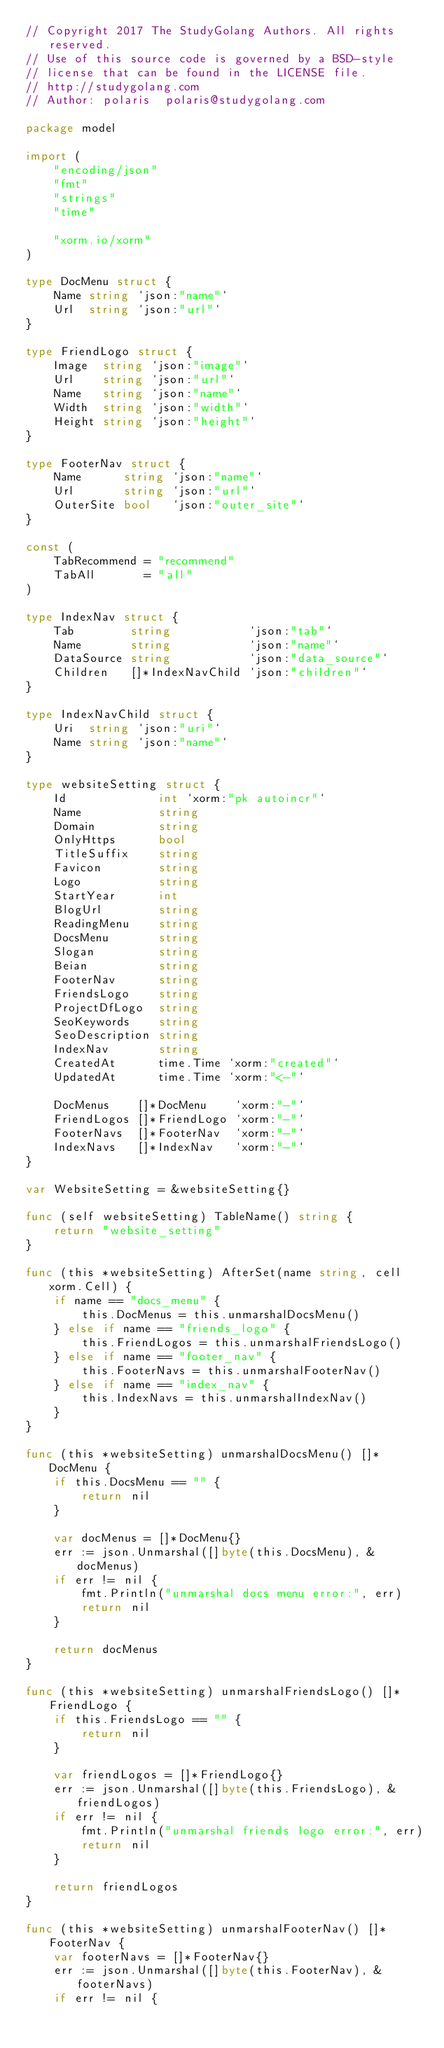<code> <loc_0><loc_0><loc_500><loc_500><_Go_>// Copyright 2017 The StudyGolang Authors. All rights reserved.
// Use of this source code is governed by a BSD-style
// license that can be found in the LICENSE file.
// http://studygolang.com
// Author: polaris	polaris@studygolang.com

package model

import (
	"encoding/json"
	"fmt"
	"strings"
	"time"

	"xorm.io/xorm"
)

type DocMenu struct {
	Name string `json:"name"`
	Url  string `json:"url"`
}

type FriendLogo struct {
	Image  string `json:"image"`
	Url    string `json:"url"`
	Name   string `json:"name"`
	Width  string `json:"width"`
	Height string `json:"height"`
}

type FooterNav struct {
	Name      string `json:"name"`
	Url       string `json:"url"`
	OuterSite bool   `json:"outer_site"`
}

const (
	TabRecommend = "recommend"
	TabAll       = "all"
)

type IndexNav struct {
	Tab        string           `json:"tab"`
	Name       string           `json:"name"`
	DataSource string           `json:"data_source"`
	Children   []*IndexNavChild `json:"children"`
}

type IndexNavChild struct {
	Uri  string `json:"uri"`
	Name string `json:"name"`
}

type websiteSetting struct {
	Id             int `xorm:"pk autoincr"`
	Name           string
	Domain         string
	OnlyHttps      bool
	TitleSuffix    string
	Favicon        string
	Logo           string
	StartYear      int
	BlogUrl        string
	ReadingMenu    string
	DocsMenu       string
	Slogan         string
	Beian          string
	FooterNav      string
	FriendsLogo    string
	ProjectDfLogo  string
	SeoKeywords    string
	SeoDescription string
	IndexNav       string
	CreatedAt      time.Time `xorm:"created"`
	UpdatedAt      time.Time `xorm:"<-"`

	DocMenus    []*DocMenu    `xorm:"-"`
	FriendLogos []*FriendLogo `xorm:"-"`
	FooterNavs  []*FooterNav  `xorm:"-"`
	IndexNavs   []*IndexNav   `xorm:"-"`
}

var WebsiteSetting = &websiteSetting{}

func (self websiteSetting) TableName() string {
	return "website_setting"
}

func (this *websiteSetting) AfterSet(name string, cell xorm.Cell) {
	if name == "docs_menu" {
		this.DocMenus = this.unmarshalDocsMenu()
	} else if name == "friends_logo" {
		this.FriendLogos = this.unmarshalFriendsLogo()
	} else if name == "footer_nav" {
		this.FooterNavs = this.unmarshalFooterNav()
	} else if name == "index_nav" {
		this.IndexNavs = this.unmarshalIndexNav()
	}
}

func (this *websiteSetting) unmarshalDocsMenu() []*DocMenu {
	if this.DocsMenu == "" {
		return nil
	}

	var docMenus = []*DocMenu{}
	err := json.Unmarshal([]byte(this.DocsMenu), &docMenus)
	if err != nil {
		fmt.Println("unmarshal docs menu error:", err)
		return nil
	}

	return docMenus
}

func (this *websiteSetting) unmarshalFriendsLogo() []*FriendLogo {
	if this.FriendsLogo == "" {
		return nil
	}

	var friendLogos = []*FriendLogo{}
	err := json.Unmarshal([]byte(this.FriendsLogo), &friendLogos)
	if err != nil {
		fmt.Println("unmarshal friends logo error:", err)
		return nil
	}

	return friendLogos
}

func (this *websiteSetting) unmarshalFooterNav() []*FooterNav {
	var footerNavs = []*FooterNav{}
	err := json.Unmarshal([]byte(this.FooterNav), &footerNavs)
	if err != nil {</code> 